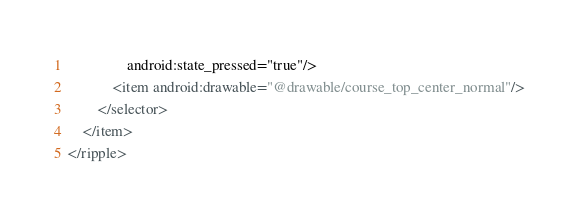Convert code to text. <code><loc_0><loc_0><loc_500><loc_500><_XML_>				android:state_pressed="true"/>
			<item android:drawable="@drawable/course_top_center_normal"/>
		</selector>
	</item>
</ripple></code> 